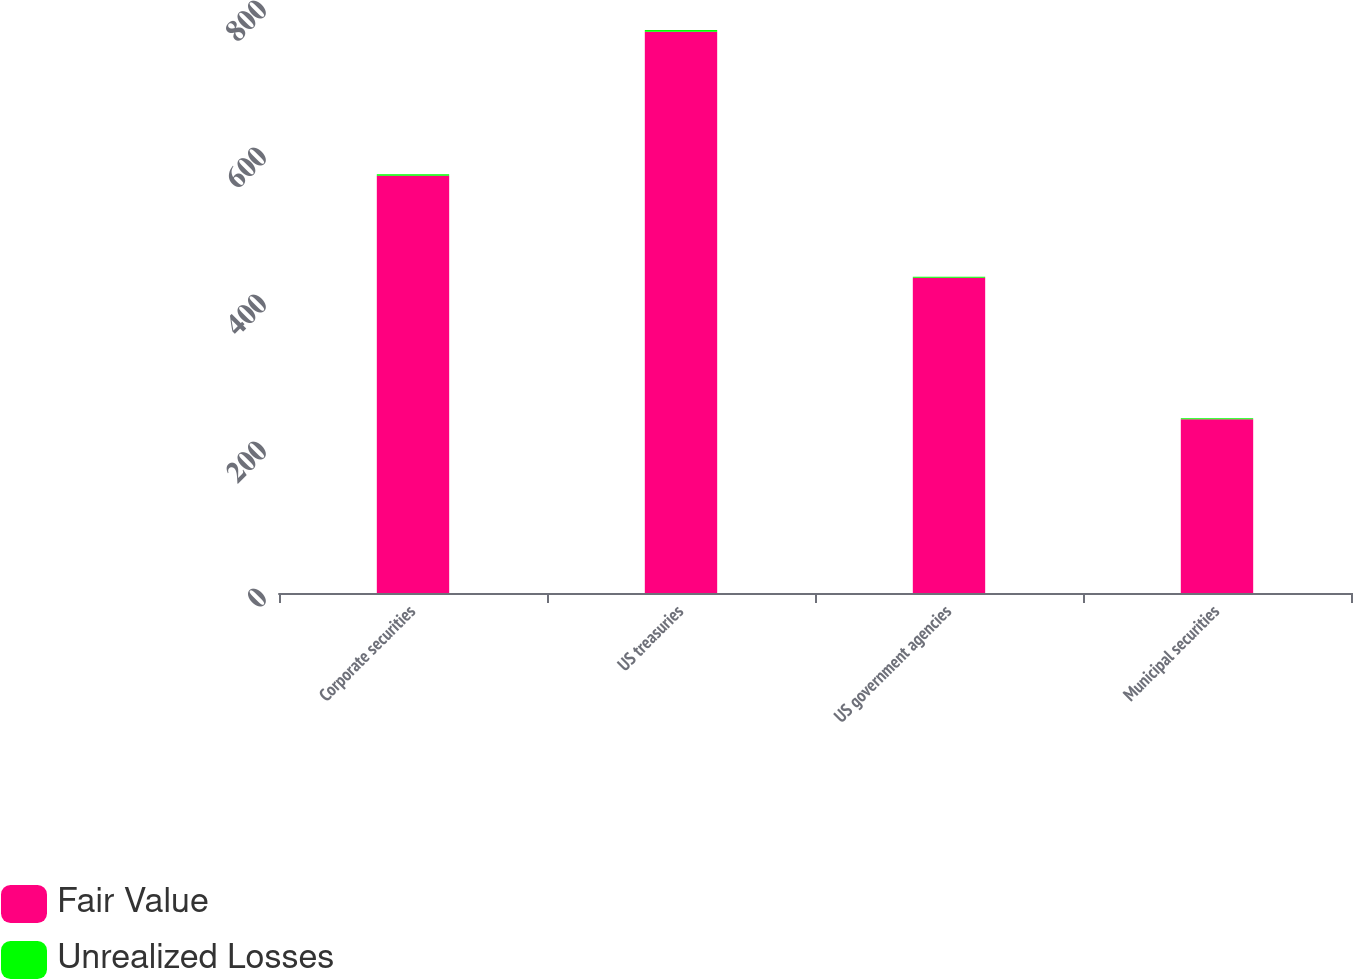Convert chart to OTSL. <chart><loc_0><loc_0><loc_500><loc_500><stacked_bar_chart><ecel><fcel>Corporate securities<fcel>US treasuries<fcel>US government agencies<fcel>Municipal securities<nl><fcel>Fair Value<fcel>567.6<fcel>763.5<fcel>428.9<fcel>236.3<nl><fcel>Unrealized Losses<fcel>2.1<fcel>2.5<fcel>1.3<fcel>1.3<nl></chart> 